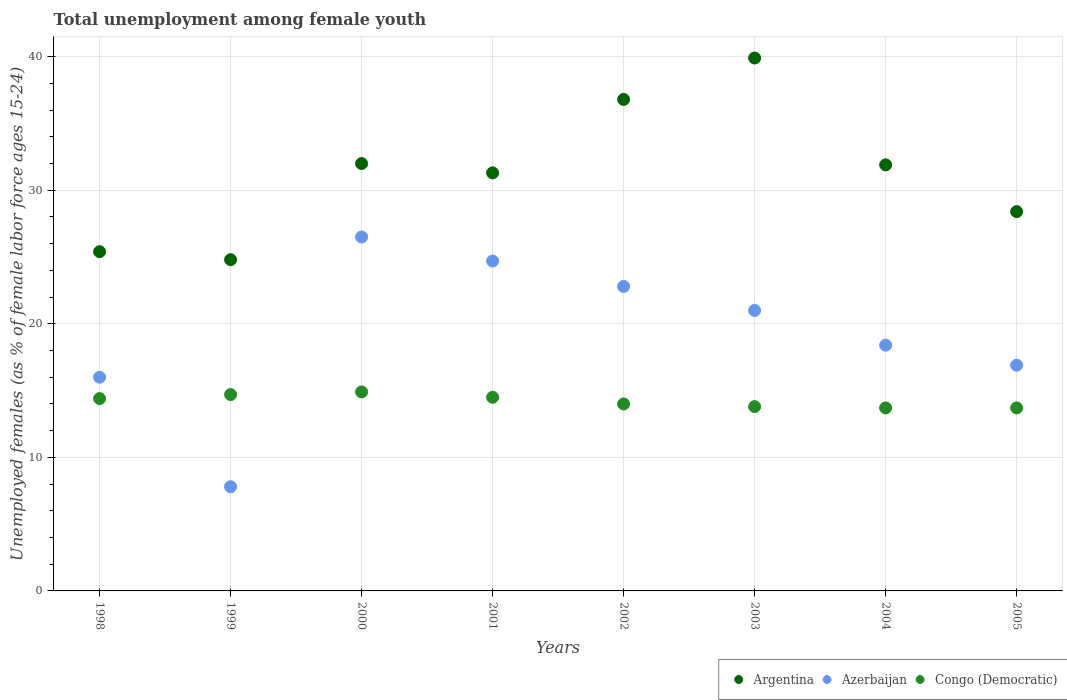How many different coloured dotlines are there?
Provide a succinct answer. 3. Is the number of dotlines equal to the number of legend labels?
Ensure brevity in your answer.  Yes. Across all years, what is the maximum percentage of unemployed females in in Argentina?
Offer a terse response. 39.9. Across all years, what is the minimum percentage of unemployed females in in Congo (Democratic)?
Ensure brevity in your answer.  13.7. In which year was the percentage of unemployed females in in Congo (Democratic) maximum?
Provide a succinct answer. 2000. In which year was the percentage of unemployed females in in Azerbaijan minimum?
Give a very brief answer. 1999. What is the total percentage of unemployed females in in Argentina in the graph?
Your answer should be compact. 250.5. What is the difference between the percentage of unemployed females in in Azerbaijan in 2000 and that in 2002?
Provide a short and direct response. 3.7. What is the difference between the percentage of unemployed females in in Congo (Democratic) in 2003 and the percentage of unemployed females in in Azerbaijan in 1999?
Ensure brevity in your answer.  6. What is the average percentage of unemployed females in in Azerbaijan per year?
Your response must be concise. 19.26. In the year 2005, what is the difference between the percentage of unemployed females in in Congo (Democratic) and percentage of unemployed females in in Azerbaijan?
Provide a succinct answer. -3.2. What is the ratio of the percentage of unemployed females in in Congo (Democratic) in 1998 to that in 2003?
Keep it short and to the point. 1.04. Is the percentage of unemployed females in in Argentina in 2000 less than that in 2001?
Make the answer very short. No. What is the difference between the highest and the second highest percentage of unemployed females in in Congo (Democratic)?
Your response must be concise. 0.2. What is the difference between the highest and the lowest percentage of unemployed females in in Argentina?
Keep it short and to the point. 15.1. Is it the case that in every year, the sum of the percentage of unemployed females in in Congo (Democratic) and percentage of unemployed females in in Azerbaijan  is greater than the percentage of unemployed females in in Argentina?
Ensure brevity in your answer.  No. Does the percentage of unemployed females in in Congo (Democratic) monotonically increase over the years?
Offer a very short reply. No. How many dotlines are there?
Offer a terse response. 3. How many years are there in the graph?
Your answer should be very brief. 8. What is the difference between two consecutive major ticks on the Y-axis?
Provide a succinct answer. 10. Are the values on the major ticks of Y-axis written in scientific E-notation?
Ensure brevity in your answer.  No. Does the graph contain grids?
Provide a succinct answer. Yes. How many legend labels are there?
Ensure brevity in your answer.  3. How are the legend labels stacked?
Offer a terse response. Horizontal. What is the title of the graph?
Provide a succinct answer. Total unemployment among female youth. Does "Sao Tome and Principe" appear as one of the legend labels in the graph?
Offer a very short reply. No. What is the label or title of the Y-axis?
Your answer should be very brief. Unemployed females (as % of female labor force ages 15-24). What is the Unemployed females (as % of female labor force ages 15-24) of Argentina in 1998?
Your answer should be very brief. 25.4. What is the Unemployed females (as % of female labor force ages 15-24) of Azerbaijan in 1998?
Offer a very short reply. 16. What is the Unemployed females (as % of female labor force ages 15-24) of Congo (Democratic) in 1998?
Make the answer very short. 14.4. What is the Unemployed females (as % of female labor force ages 15-24) in Argentina in 1999?
Provide a succinct answer. 24.8. What is the Unemployed females (as % of female labor force ages 15-24) in Azerbaijan in 1999?
Keep it short and to the point. 7.8. What is the Unemployed females (as % of female labor force ages 15-24) in Congo (Democratic) in 1999?
Your response must be concise. 14.7. What is the Unemployed females (as % of female labor force ages 15-24) in Argentina in 2000?
Offer a very short reply. 32. What is the Unemployed females (as % of female labor force ages 15-24) in Azerbaijan in 2000?
Ensure brevity in your answer.  26.5. What is the Unemployed females (as % of female labor force ages 15-24) in Congo (Democratic) in 2000?
Give a very brief answer. 14.9. What is the Unemployed females (as % of female labor force ages 15-24) in Argentina in 2001?
Your answer should be compact. 31.3. What is the Unemployed females (as % of female labor force ages 15-24) in Azerbaijan in 2001?
Provide a short and direct response. 24.7. What is the Unemployed females (as % of female labor force ages 15-24) in Congo (Democratic) in 2001?
Provide a succinct answer. 14.5. What is the Unemployed females (as % of female labor force ages 15-24) of Argentina in 2002?
Your answer should be compact. 36.8. What is the Unemployed females (as % of female labor force ages 15-24) of Azerbaijan in 2002?
Provide a short and direct response. 22.8. What is the Unemployed females (as % of female labor force ages 15-24) of Congo (Democratic) in 2002?
Give a very brief answer. 14. What is the Unemployed females (as % of female labor force ages 15-24) of Argentina in 2003?
Give a very brief answer. 39.9. What is the Unemployed females (as % of female labor force ages 15-24) of Congo (Democratic) in 2003?
Offer a terse response. 13.8. What is the Unemployed females (as % of female labor force ages 15-24) in Argentina in 2004?
Keep it short and to the point. 31.9. What is the Unemployed females (as % of female labor force ages 15-24) of Azerbaijan in 2004?
Your answer should be very brief. 18.4. What is the Unemployed females (as % of female labor force ages 15-24) of Congo (Democratic) in 2004?
Your response must be concise. 13.7. What is the Unemployed females (as % of female labor force ages 15-24) in Argentina in 2005?
Your answer should be very brief. 28.4. What is the Unemployed females (as % of female labor force ages 15-24) of Azerbaijan in 2005?
Provide a short and direct response. 16.9. What is the Unemployed females (as % of female labor force ages 15-24) of Congo (Democratic) in 2005?
Give a very brief answer. 13.7. Across all years, what is the maximum Unemployed females (as % of female labor force ages 15-24) in Argentina?
Your response must be concise. 39.9. Across all years, what is the maximum Unemployed females (as % of female labor force ages 15-24) of Congo (Democratic)?
Make the answer very short. 14.9. Across all years, what is the minimum Unemployed females (as % of female labor force ages 15-24) in Argentina?
Give a very brief answer. 24.8. Across all years, what is the minimum Unemployed females (as % of female labor force ages 15-24) in Azerbaijan?
Offer a terse response. 7.8. Across all years, what is the minimum Unemployed females (as % of female labor force ages 15-24) in Congo (Democratic)?
Make the answer very short. 13.7. What is the total Unemployed females (as % of female labor force ages 15-24) of Argentina in the graph?
Provide a succinct answer. 250.5. What is the total Unemployed females (as % of female labor force ages 15-24) of Azerbaijan in the graph?
Give a very brief answer. 154.1. What is the total Unemployed females (as % of female labor force ages 15-24) in Congo (Democratic) in the graph?
Give a very brief answer. 113.7. What is the difference between the Unemployed females (as % of female labor force ages 15-24) in Argentina in 1998 and that in 1999?
Your answer should be compact. 0.6. What is the difference between the Unemployed females (as % of female labor force ages 15-24) in Azerbaijan in 1998 and that in 1999?
Keep it short and to the point. 8.2. What is the difference between the Unemployed females (as % of female labor force ages 15-24) in Argentina in 1998 and that in 2000?
Make the answer very short. -6.6. What is the difference between the Unemployed females (as % of female labor force ages 15-24) of Azerbaijan in 1998 and that in 2000?
Give a very brief answer. -10.5. What is the difference between the Unemployed females (as % of female labor force ages 15-24) in Azerbaijan in 1998 and that in 2001?
Offer a terse response. -8.7. What is the difference between the Unemployed females (as % of female labor force ages 15-24) of Azerbaijan in 1998 and that in 2002?
Your answer should be compact. -6.8. What is the difference between the Unemployed females (as % of female labor force ages 15-24) of Argentina in 1998 and that in 2004?
Give a very brief answer. -6.5. What is the difference between the Unemployed females (as % of female labor force ages 15-24) in Argentina in 1998 and that in 2005?
Make the answer very short. -3. What is the difference between the Unemployed females (as % of female labor force ages 15-24) of Azerbaijan in 1998 and that in 2005?
Offer a terse response. -0.9. What is the difference between the Unemployed females (as % of female labor force ages 15-24) in Argentina in 1999 and that in 2000?
Your answer should be compact. -7.2. What is the difference between the Unemployed females (as % of female labor force ages 15-24) of Azerbaijan in 1999 and that in 2000?
Offer a very short reply. -18.7. What is the difference between the Unemployed females (as % of female labor force ages 15-24) of Argentina in 1999 and that in 2001?
Make the answer very short. -6.5. What is the difference between the Unemployed females (as % of female labor force ages 15-24) in Azerbaijan in 1999 and that in 2001?
Offer a terse response. -16.9. What is the difference between the Unemployed females (as % of female labor force ages 15-24) in Congo (Democratic) in 1999 and that in 2001?
Make the answer very short. 0.2. What is the difference between the Unemployed females (as % of female labor force ages 15-24) of Azerbaijan in 1999 and that in 2002?
Your answer should be compact. -15. What is the difference between the Unemployed females (as % of female labor force ages 15-24) in Congo (Democratic) in 1999 and that in 2002?
Offer a terse response. 0.7. What is the difference between the Unemployed females (as % of female labor force ages 15-24) of Argentina in 1999 and that in 2003?
Ensure brevity in your answer.  -15.1. What is the difference between the Unemployed females (as % of female labor force ages 15-24) of Argentina in 1999 and that in 2004?
Offer a very short reply. -7.1. What is the difference between the Unemployed females (as % of female labor force ages 15-24) in Azerbaijan in 1999 and that in 2004?
Offer a terse response. -10.6. What is the difference between the Unemployed females (as % of female labor force ages 15-24) in Congo (Democratic) in 1999 and that in 2004?
Offer a terse response. 1. What is the difference between the Unemployed females (as % of female labor force ages 15-24) in Azerbaijan in 1999 and that in 2005?
Provide a short and direct response. -9.1. What is the difference between the Unemployed females (as % of female labor force ages 15-24) in Congo (Democratic) in 1999 and that in 2005?
Ensure brevity in your answer.  1. What is the difference between the Unemployed females (as % of female labor force ages 15-24) of Congo (Democratic) in 2000 and that in 2001?
Your response must be concise. 0.4. What is the difference between the Unemployed females (as % of female labor force ages 15-24) in Argentina in 2000 and that in 2002?
Your response must be concise. -4.8. What is the difference between the Unemployed females (as % of female labor force ages 15-24) of Azerbaijan in 2000 and that in 2002?
Your response must be concise. 3.7. What is the difference between the Unemployed females (as % of female labor force ages 15-24) of Congo (Democratic) in 2000 and that in 2002?
Give a very brief answer. 0.9. What is the difference between the Unemployed females (as % of female labor force ages 15-24) of Argentina in 2000 and that in 2004?
Give a very brief answer. 0.1. What is the difference between the Unemployed females (as % of female labor force ages 15-24) of Azerbaijan in 2000 and that in 2004?
Provide a short and direct response. 8.1. What is the difference between the Unemployed females (as % of female labor force ages 15-24) of Argentina in 2000 and that in 2005?
Keep it short and to the point. 3.6. What is the difference between the Unemployed females (as % of female labor force ages 15-24) of Azerbaijan in 2000 and that in 2005?
Keep it short and to the point. 9.6. What is the difference between the Unemployed females (as % of female labor force ages 15-24) of Azerbaijan in 2001 and that in 2002?
Your answer should be very brief. 1.9. What is the difference between the Unemployed females (as % of female labor force ages 15-24) in Argentina in 2001 and that in 2004?
Your answer should be compact. -0.6. What is the difference between the Unemployed females (as % of female labor force ages 15-24) in Congo (Democratic) in 2001 and that in 2004?
Your answer should be compact. 0.8. What is the difference between the Unemployed females (as % of female labor force ages 15-24) in Argentina in 2001 and that in 2005?
Provide a short and direct response. 2.9. What is the difference between the Unemployed females (as % of female labor force ages 15-24) in Azerbaijan in 2001 and that in 2005?
Your response must be concise. 7.8. What is the difference between the Unemployed females (as % of female labor force ages 15-24) of Argentina in 2002 and that in 2003?
Your answer should be compact. -3.1. What is the difference between the Unemployed females (as % of female labor force ages 15-24) of Azerbaijan in 2002 and that in 2003?
Provide a short and direct response. 1.8. What is the difference between the Unemployed females (as % of female labor force ages 15-24) in Argentina in 2002 and that in 2004?
Offer a terse response. 4.9. What is the difference between the Unemployed females (as % of female labor force ages 15-24) of Azerbaijan in 2002 and that in 2004?
Your answer should be compact. 4.4. What is the difference between the Unemployed females (as % of female labor force ages 15-24) in Congo (Democratic) in 2002 and that in 2004?
Your answer should be very brief. 0.3. What is the difference between the Unemployed females (as % of female labor force ages 15-24) in Azerbaijan in 2002 and that in 2005?
Give a very brief answer. 5.9. What is the difference between the Unemployed females (as % of female labor force ages 15-24) of Congo (Democratic) in 2002 and that in 2005?
Make the answer very short. 0.3. What is the difference between the Unemployed females (as % of female labor force ages 15-24) of Azerbaijan in 2003 and that in 2004?
Your response must be concise. 2.6. What is the difference between the Unemployed females (as % of female labor force ages 15-24) of Argentina in 2004 and that in 2005?
Your answer should be compact. 3.5. What is the difference between the Unemployed females (as % of female labor force ages 15-24) of Azerbaijan in 2004 and that in 2005?
Make the answer very short. 1.5. What is the difference between the Unemployed females (as % of female labor force ages 15-24) in Congo (Democratic) in 2004 and that in 2005?
Keep it short and to the point. 0. What is the difference between the Unemployed females (as % of female labor force ages 15-24) of Argentina in 1998 and the Unemployed females (as % of female labor force ages 15-24) of Azerbaijan in 1999?
Your answer should be very brief. 17.6. What is the difference between the Unemployed females (as % of female labor force ages 15-24) in Argentina in 1998 and the Unemployed females (as % of female labor force ages 15-24) in Congo (Democratic) in 1999?
Keep it short and to the point. 10.7. What is the difference between the Unemployed females (as % of female labor force ages 15-24) in Azerbaijan in 1998 and the Unemployed females (as % of female labor force ages 15-24) in Congo (Democratic) in 1999?
Ensure brevity in your answer.  1.3. What is the difference between the Unemployed females (as % of female labor force ages 15-24) of Argentina in 1998 and the Unemployed females (as % of female labor force ages 15-24) of Congo (Democratic) in 2000?
Ensure brevity in your answer.  10.5. What is the difference between the Unemployed females (as % of female labor force ages 15-24) in Argentina in 1998 and the Unemployed females (as % of female labor force ages 15-24) in Azerbaijan in 2001?
Ensure brevity in your answer.  0.7. What is the difference between the Unemployed females (as % of female labor force ages 15-24) of Argentina in 1998 and the Unemployed females (as % of female labor force ages 15-24) of Congo (Democratic) in 2001?
Make the answer very short. 10.9. What is the difference between the Unemployed females (as % of female labor force ages 15-24) of Argentina in 1998 and the Unemployed females (as % of female labor force ages 15-24) of Azerbaijan in 2002?
Ensure brevity in your answer.  2.6. What is the difference between the Unemployed females (as % of female labor force ages 15-24) in Argentina in 1998 and the Unemployed females (as % of female labor force ages 15-24) in Congo (Democratic) in 2002?
Make the answer very short. 11.4. What is the difference between the Unemployed females (as % of female labor force ages 15-24) of Azerbaijan in 1998 and the Unemployed females (as % of female labor force ages 15-24) of Congo (Democratic) in 2002?
Make the answer very short. 2. What is the difference between the Unemployed females (as % of female labor force ages 15-24) in Argentina in 1998 and the Unemployed females (as % of female labor force ages 15-24) in Azerbaijan in 2003?
Provide a succinct answer. 4.4. What is the difference between the Unemployed females (as % of female labor force ages 15-24) in Argentina in 1998 and the Unemployed females (as % of female labor force ages 15-24) in Congo (Democratic) in 2003?
Offer a very short reply. 11.6. What is the difference between the Unemployed females (as % of female labor force ages 15-24) of Azerbaijan in 1998 and the Unemployed females (as % of female labor force ages 15-24) of Congo (Democratic) in 2003?
Give a very brief answer. 2.2. What is the difference between the Unemployed females (as % of female labor force ages 15-24) of Argentina in 1998 and the Unemployed females (as % of female labor force ages 15-24) of Azerbaijan in 2004?
Offer a very short reply. 7. What is the difference between the Unemployed females (as % of female labor force ages 15-24) of Argentina in 1998 and the Unemployed females (as % of female labor force ages 15-24) of Azerbaijan in 2005?
Ensure brevity in your answer.  8.5. What is the difference between the Unemployed females (as % of female labor force ages 15-24) in Azerbaijan in 1998 and the Unemployed females (as % of female labor force ages 15-24) in Congo (Democratic) in 2005?
Ensure brevity in your answer.  2.3. What is the difference between the Unemployed females (as % of female labor force ages 15-24) in Argentina in 1999 and the Unemployed females (as % of female labor force ages 15-24) in Azerbaijan in 2000?
Ensure brevity in your answer.  -1.7. What is the difference between the Unemployed females (as % of female labor force ages 15-24) of Argentina in 1999 and the Unemployed females (as % of female labor force ages 15-24) of Azerbaijan in 2002?
Ensure brevity in your answer.  2. What is the difference between the Unemployed females (as % of female labor force ages 15-24) in Azerbaijan in 1999 and the Unemployed females (as % of female labor force ages 15-24) in Congo (Democratic) in 2002?
Give a very brief answer. -6.2. What is the difference between the Unemployed females (as % of female labor force ages 15-24) in Argentina in 1999 and the Unemployed females (as % of female labor force ages 15-24) in Azerbaijan in 2003?
Offer a terse response. 3.8. What is the difference between the Unemployed females (as % of female labor force ages 15-24) in Argentina in 1999 and the Unemployed females (as % of female labor force ages 15-24) in Congo (Democratic) in 2003?
Your answer should be compact. 11. What is the difference between the Unemployed females (as % of female labor force ages 15-24) in Argentina in 1999 and the Unemployed females (as % of female labor force ages 15-24) in Azerbaijan in 2004?
Ensure brevity in your answer.  6.4. What is the difference between the Unemployed females (as % of female labor force ages 15-24) of Argentina in 1999 and the Unemployed females (as % of female labor force ages 15-24) of Congo (Democratic) in 2004?
Your response must be concise. 11.1. What is the difference between the Unemployed females (as % of female labor force ages 15-24) in Argentina in 2000 and the Unemployed females (as % of female labor force ages 15-24) in Azerbaijan in 2001?
Your answer should be very brief. 7.3. What is the difference between the Unemployed females (as % of female labor force ages 15-24) in Argentina in 2000 and the Unemployed females (as % of female labor force ages 15-24) in Congo (Democratic) in 2001?
Offer a terse response. 17.5. What is the difference between the Unemployed females (as % of female labor force ages 15-24) of Azerbaijan in 2000 and the Unemployed females (as % of female labor force ages 15-24) of Congo (Democratic) in 2001?
Provide a short and direct response. 12. What is the difference between the Unemployed females (as % of female labor force ages 15-24) in Argentina in 2000 and the Unemployed females (as % of female labor force ages 15-24) in Azerbaijan in 2002?
Keep it short and to the point. 9.2. What is the difference between the Unemployed females (as % of female labor force ages 15-24) in Azerbaijan in 2000 and the Unemployed females (as % of female labor force ages 15-24) in Congo (Democratic) in 2002?
Ensure brevity in your answer.  12.5. What is the difference between the Unemployed females (as % of female labor force ages 15-24) in Azerbaijan in 2000 and the Unemployed females (as % of female labor force ages 15-24) in Congo (Democratic) in 2003?
Give a very brief answer. 12.7. What is the difference between the Unemployed females (as % of female labor force ages 15-24) of Argentina in 2000 and the Unemployed females (as % of female labor force ages 15-24) of Azerbaijan in 2004?
Your answer should be compact. 13.6. What is the difference between the Unemployed females (as % of female labor force ages 15-24) in Argentina in 2000 and the Unemployed females (as % of female labor force ages 15-24) in Azerbaijan in 2005?
Give a very brief answer. 15.1. What is the difference between the Unemployed females (as % of female labor force ages 15-24) in Argentina in 2001 and the Unemployed females (as % of female labor force ages 15-24) in Azerbaijan in 2002?
Offer a terse response. 8.5. What is the difference between the Unemployed females (as % of female labor force ages 15-24) in Azerbaijan in 2001 and the Unemployed females (as % of female labor force ages 15-24) in Congo (Democratic) in 2002?
Ensure brevity in your answer.  10.7. What is the difference between the Unemployed females (as % of female labor force ages 15-24) in Argentina in 2001 and the Unemployed females (as % of female labor force ages 15-24) in Azerbaijan in 2003?
Your response must be concise. 10.3. What is the difference between the Unemployed females (as % of female labor force ages 15-24) in Argentina in 2001 and the Unemployed females (as % of female labor force ages 15-24) in Congo (Democratic) in 2003?
Give a very brief answer. 17.5. What is the difference between the Unemployed females (as % of female labor force ages 15-24) in Argentina in 2001 and the Unemployed females (as % of female labor force ages 15-24) in Azerbaijan in 2004?
Provide a succinct answer. 12.9. What is the difference between the Unemployed females (as % of female labor force ages 15-24) of Azerbaijan in 2001 and the Unemployed females (as % of female labor force ages 15-24) of Congo (Democratic) in 2004?
Make the answer very short. 11. What is the difference between the Unemployed females (as % of female labor force ages 15-24) of Argentina in 2001 and the Unemployed females (as % of female labor force ages 15-24) of Azerbaijan in 2005?
Your response must be concise. 14.4. What is the difference between the Unemployed females (as % of female labor force ages 15-24) of Azerbaijan in 2001 and the Unemployed females (as % of female labor force ages 15-24) of Congo (Democratic) in 2005?
Provide a succinct answer. 11. What is the difference between the Unemployed females (as % of female labor force ages 15-24) in Argentina in 2002 and the Unemployed females (as % of female labor force ages 15-24) in Azerbaijan in 2003?
Keep it short and to the point. 15.8. What is the difference between the Unemployed females (as % of female labor force ages 15-24) in Azerbaijan in 2002 and the Unemployed females (as % of female labor force ages 15-24) in Congo (Democratic) in 2003?
Offer a terse response. 9. What is the difference between the Unemployed females (as % of female labor force ages 15-24) of Argentina in 2002 and the Unemployed females (as % of female labor force ages 15-24) of Azerbaijan in 2004?
Your response must be concise. 18.4. What is the difference between the Unemployed females (as % of female labor force ages 15-24) in Argentina in 2002 and the Unemployed females (as % of female labor force ages 15-24) in Congo (Democratic) in 2004?
Give a very brief answer. 23.1. What is the difference between the Unemployed females (as % of female labor force ages 15-24) in Azerbaijan in 2002 and the Unemployed females (as % of female labor force ages 15-24) in Congo (Democratic) in 2004?
Give a very brief answer. 9.1. What is the difference between the Unemployed females (as % of female labor force ages 15-24) of Argentina in 2002 and the Unemployed females (as % of female labor force ages 15-24) of Congo (Democratic) in 2005?
Your answer should be very brief. 23.1. What is the difference between the Unemployed females (as % of female labor force ages 15-24) of Azerbaijan in 2002 and the Unemployed females (as % of female labor force ages 15-24) of Congo (Democratic) in 2005?
Your answer should be very brief. 9.1. What is the difference between the Unemployed females (as % of female labor force ages 15-24) in Argentina in 2003 and the Unemployed females (as % of female labor force ages 15-24) in Congo (Democratic) in 2004?
Keep it short and to the point. 26.2. What is the difference between the Unemployed females (as % of female labor force ages 15-24) in Argentina in 2003 and the Unemployed females (as % of female labor force ages 15-24) in Azerbaijan in 2005?
Give a very brief answer. 23. What is the difference between the Unemployed females (as % of female labor force ages 15-24) of Argentina in 2003 and the Unemployed females (as % of female labor force ages 15-24) of Congo (Democratic) in 2005?
Ensure brevity in your answer.  26.2. What is the difference between the Unemployed females (as % of female labor force ages 15-24) of Argentina in 2004 and the Unemployed females (as % of female labor force ages 15-24) of Azerbaijan in 2005?
Keep it short and to the point. 15. What is the average Unemployed females (as % of female labor force ages 15-24) of Argentina per year?
Offer a very short reply. 31.31. What is the average Unemployed females (as % of female labor force ages 15-24) in Azerbaijan per year?
Offer a very short reply. 19.26. What is the average Unemployed females (as % of female labor force ages 15-24) in Congo (Democratic) per year?
Offer a very short reply. 14.21. In the year 1998, what is the difference between the Unemployed females (as % of female labor force ages 15-24) in Argentina and Unemployed females (as % of female labor force ages 15-24) in Azerbaijan?
Provide a short and direct response. 9.4. In the year 1998, what is the difference between the Unemployed females (as % of female labor force ages 15-24) in Argentina and Unemployed females (as % of female labor force ages 15-24) in Congo (Democratic)?
Offer a terse response. 11. In the year 1999, what is the difference between the Unemployed females (as % of female labor force ages 15-24) of Argentina and Unemployed females (as % of female labor force ages 15-24) of Azerbaijan?
Provide a succinct answer. 17. In the year 1999, what is the difference between the Unemployed females (as % of female labor force ages 15-24) in Azerbaijan and Unemployed females (as % of female labor force ages 15-24) in Congo (Democratic)?
Make the answer very short. -6.9. In the year 2001, what is the difference between the Unemployed females (as % of female labor force ages 15-24) of Argentina and Unemployed females (as % of female labor force ages 15-24) of Congo (Democratic)?
Your answer should be compact. 16.8. In the year 2001, what is the difference between the Unemployed females (as % of female labor force ages 15-24) in Azerbaijan and Unemployed females (as % of female labor force ages 15-24) in Congo (Democratic)?
Give a very brief answer. 10.2. In the year 2002, what is the difference between the Unemployed females (as % of female labor force ages 15-24) of Argentina and Unemployed females (as % of female labor force ages 15-24) of Congo (Democratic)?
Offer a very short reply. 22.8. In the year 2002, what is the difference between the Unemployed females (as % of female labor force ages 15-24) in Azerbaijan and Unemployed females (as % of female labor force ages 15-24) in Congo (Democratic)?
Your answer should be very brief. 8.8. In the year 2003, what is the difference between the Unemployed females (as % of female labor force ages 15-24) in Argentina and Unemployed females (as % of female labor force ages 15-24) in Azerbaijan?
Ensure brevity in your answer.  18.9. In the year 2003, what is the difference between the Unemployed females (as % of female labor force ages 15-24) in Argentina and Unemployed females (as % of female labor force ages 15-24) in Congo (Democratic)?
Offer a very short reply. 26.1. In the year 2003, what is the difference between the Unemployed females (as % of female labor force ages 15-24) of Azerbaijan and Unemployed females (as % of female labor force ages 15-24) of Congo (Democratic)?
Make the answer very short. 7.2. What is the ratio of the Unemployed females (as % of female labor force ages 15-24) of Argentina in 1998 to that in 1999?
Provide a short and direct response. 1.02. What is the ratio of the Unemployed females (as % of female labor force ages 15-24) of Azerbaijan in 1998 to that in 1999?
Keep it short and to the point. 2.05. What is the ratio of the Unemployed females (as % of female labor force ages 15-24) in Congo (Democratic) in 1998 to that in 1999?
Provide a short and direct response. 0.98. What is the ratio of the Unemployed females (as % of female labor force ages 15-24) in Argentina in 1998 to that in 2000?
Ensure brevity in your answer.  0.79. What is the ratio of the Unemployed females (as % of female labor force ages 15-24) of Azerbaijan in 1998 to that in 2000?
Offer a terse response. 0.6. What is the ratio of the Unemployed females (as % of female labor force ages 15-24) in Congo (Democratic) in 1998 to that in 2000?
Give a very brief answer. 0.97. What is the ratio of the Unemployed females (as % of female labor force ages 15-24) in Argentina in 1998 to that in 2001?
Give a very brief answer. 0.81. What is the ratio of the Unemployed females (as % of female labor force ages 15-24) in Azerbaijan in 1998 to that in 2001?
Your answer should be very brief. 0.65. What is the ratio of the Unemployed females (as % of female labor force ages 15-24) of Congo (Democratic) in 1998 to that in 2001?
Provide a short and direct response. 0.99. What is the ratio of the Unemployed females (as % of female labor force ages 15-24) of Argentina in 1998 to that in 2002?
Your response must be concise. 0.69. What is the ratio of the Unemployed females (as % of female labor force ages 15-24) of Azerbaijan in 1998 to that in 2002?
Provide a short and direct response. 0.7. What is the ratio of the Unemployed females (as % of female labor force ages 15-24) of Congo (Democratic) in 1998 to that in 2002?
Give a very brief answer. 1.03. What is the ratio of the Unemployed females (as % of female labor force ages 15-24) of Argentina in 1998 to that in 2003?
Give a very brief answer. 0.64. What is the ratio of the Unemployed females (as % of female labor force ages 15-24) of Azerbaijan in 1998 to that in 2003?
Keep it short and to the point. 0.76. What is the ratio of the Unemployed females (as % of female labor force ages 15-24) in Congo (Democratic) in 1998 to that in 2003?
Keep it short and to the point. 1.04. What is the ratio of the Unemployed females (as % of female labor force ages 15-24) in Argentina in 1998 to that in 2004?
Your answer should be very brief. 0.8. What is the ratio of the Unemployed females (as % of female labor force ages 15-24) of Azerbaijan in 1998 to that in 2004?
Ensure brevity in your answer.  0.87. What is the ratio of the Unemployed females (as % of female labor force ages 15-24) in Congo (Democratic) in 1998 to that in 2004?
Keep it short and to the point. 1.05. What is the ratio of the Unemployed females (as % of female labor force ages 15-24) of Argentina in 1998 to that in 2005?
Give a very brief answer. 0.89. What is the ratio of the Unemployed females (as % of female labor force ages 15-24) of Azerbaijan in 1998 to that in 2005?
Make the answer very short. 0.95. What is the ratio of the Unemployed females (as % of female labor force ages 15-24) of Congo (Democratic) in 1998 to that in 2005?
Make the answer very short. 1.05. What is the ratio of the Unemployed females (as % of female labor force ages 15-24) of Argentina in 1999 to that in 2000?
Offer a terse response. 0.78. What is the ratio of the Unemployed females (as % of female labor force ages 15-24) in Azerbaijan in 1999 to that in 2000?
Offer a very short reply. 0.29. What is the ratio of the Unemployed females (as % of female labor force ages 15-24) of Congo (Democratic) in 1999 to that in 2000?
Give a very brief answer. 0.99. What is the ratio of the Unemployed females (as % of female labor force ages 15-24) of Argentina in 1999 to that in 2001?
Keep it short and to the point. 0.79. What is the ratio of the Unemployed females (as % of female labor force ages 15-24) in Azerbaijan in 1999 to that in 2001?
Keep it short and to the point. 0.32. What is the ratio of the Unemployed females (as % of female labor force ages 15-24) of Congo (Democratic) in 1999 to that in 2001?
Your response must be concise. 1.01. What is the ratio of the Unemployed females (as % of female labor force ages 15-24) of Argentina in 1999 to that in 2002?
Offer a very short reply. 0.67. What is the ratio of the Unemployed females (as % of female labor force ages 15-24) of Azerbaijan in 1999 to that in 2002?
Ensure brevity in your answer.  0.34. What is the ratio of the Unemployed females (as % of female labor force ages 15-24) of Congo (Democratic) in 1999 to that in 2002?
Provide a short and direct response. 1.05. What is the ratio of the Unemployed females (as % of female labor force ages 15-24) of Argentina in 1999 to that in 2003?
Give a very brief answer. 0.62. What is the ratio of the Unemployed females (as % of female labor force ages 15-24) in Azerbaijan in 1999 to that in 2003?
Provide a succinct answer. 0.37. What is the ratio of the Unemployed females (as % of female labor force ages 15-24) in Congo (Democratic) in 1999 to that in 2003?
Ensure brevity in your answer.  1.07. What is the ratio of the Unemployed females (as % of female labor force ages 15-24) in Argentina in 1999 to that in 2004?
Your answer should be compact. 0.78. What is the ratio of the Unemployed females (as % of female labor force ages 15-24) of Azerbaijan in 1999 to that in 2004?
Make the answer very short. 0.42. What is the ratio of the Unemployed females (as % of female labor force ages 15-24) in Congo (Democratic) in 1999 to that in 2004?
Keep it short and to the point. 1.07. What is the ratio of the Unemployed females (as % of female labor force ages 15-24) of Argentina in 1999 to that in 2005?
Give a very brief answer. 0.87. What is the ratio of the Unemployed females (as % of female labor force ages 15-24) of Azerbaijan in 1999 to that in 2005?
Your answer should be compact. 0.46. What is the ratio of the Unemployed females (as % of female labor force ages 15-24) in Congo (Democratic) in 1999 to that in 2005?
Your response must be concise. 1.07. What is the ratio of the Unemployed females (as % of female labor force ages 15-24) of Argentina in 2000 to that in 2001?
Provide a succinct answer. 1.02. What is the ratio of the Unemployed females (as % of female labor force ages 15-24) of Azerbaijan in 2000 to that in 2001?
Give a very brief answer. 1.07. What is the ratio of the Unemployed females (as % of female labor force ages 15-24) of Congo (Democratic) in 2000 to that in 2001?
Provide a succinct answer. 1.03. What is the ratio of the Unemployed females (as % of female labor force ages 15-24) of Argentina in 2000 to that in 2002?
Keep it short and to the point. 0.87. What is the ratio of the Unemployed females (as % of female labor force ages 15-24) in Azerbaijan in 2000 to that in 2002?
Your answer should be very brief. 1.16. What is the ratio of the Unemployed females (as % of female labor force ages 15-24) in Congo (Democratic) in 2000 to that in 2002?
Make the answer very short. 1.06. What is the ratio of the Unemployed females (as % of female labor force ages 15-24) of Argentina in 2000 to that in 2003?
Your response must be concise. 0.8. What is the ratio of the Unemployed females (as % of female labor force ages 15-24) in Azerbaijan in 2000 to that in 2003?
Ensure brevity in your answer.  1.26. What is the ratio of the Unemployed females (as % of female labor force ages 15-24) of Congo (Democratic) in 2000 to that in 2003?
Your answer should be very brief. 1.08. What is the ratio of the Unemployed females (as % of female labor force ages 15-24) of Azerbaijan in 2000 to that in 2004?
Offer a very short reply. 1.44. What is the ratio of the Unemployed females (as % of female labor force ages 15-24) of Congo (Democratic) in 2000 to that in 2004?
Offer a very short reply. 1.09. What is the ratio of the Unemployed females (as % of female labor force ages 15-24) of Argentina in 2000 to that in 2005?
Your answer should be compact. 1.13. What is the ratio of the Unemployed females (as % of female labor force ages 15-24) of Azerbaijan in 2000 to that in 2005?
Offer a very short reply. 1.57. What is the ratio of the Unemployed females (as % of female labor force ages 15-24) of Congo (Democratic) in 2000 to that in 2005?
Provide a succinct answer. 1.09. What is the ratio of the Unemployed females (as % of female labor force ages 15-24) of Argentina in 2001 to that in 2002?
Give a very brief answer. 0.85. What is the ratio of the Unemployed females (as % of female labor force ages 15-24) of Congo (Democratic) in 2001 to that in 2002?
Keep it short and to the point. 1.04. What is the ratio of the Unemployed females (as % of female labor force ages 15-24) of Argentina in 2001 to that in 2003?
Your answer should be very brief. 0.78. What is the ratio of the Unemployed females (as % of female labor force ages 15-24) of Azerbaijan in 2001 to that in 2003?
Ensure brevity in your answer.  1.18. What is the ratio of the Unemployed females (as % of female labor force ages 15-24) in Congo (Democratic) in 2001 to that in 2003?
Give a very brief answer. 1.05. What is the ratio of the Unemployed females (as % of female labor force ages 15-24) of Argentina in 2001 to that in 2004?
Make the answer very short. 0.98. What is the ratio of the Unemployed females (as % of female labor force ages 15-24) in Azerbaijan in 2001 to that in 2004?
Give a very brief answer. 1.34. What is the ratio of the Unemployed females (as % of female labor force ages 15-24) in Congo (Democratic) in 2001 to that in 2004?
Ensure brevity in your answer.  1.06. What is the ratio of the Unemployed females (as % of female labor force ages 15-24) of Argentina in 2001 to that in 2005?
Give a very brief answer. 1.1. What is the ratio of the Unemployed females (as % of female labor force ages 15-24) in Azerbaijan in 2001 to that in 2005?
Provide a short and direct response. 1.46. What is the ratio of the Unemployed females (as % of female labor force ages 15-24) in Congo (Democratic) in 2001 to that in 2005?
Your answer should be compact. 1.06. What is the ratio of the Unemployed females (as % of female labor force ages 15-24) in Argentina in 2002 to that in 2003?
Your answer should be very brief. 0.92. What is the ratio of the Unemployed females (as % of female labor force ages 15-24) of Azerbaijan in 2002 to that in 2003?
Keep it short and to the point. 1.09. What is the ratio of the Unemployed females (as % of female labor force ages 15-24) of Congo (Democratic) in 2002 to that in 2003?
Your answer should be compact. 1.01. What is the ratio of the Unemployed females (as % of female labor force ages 15-24) in Argentina in 2002 to that in 2004?
Give a very brief answer. 1.15. What is the ratio of the Unemployed females (as % of female labor force ages 15-24) in Azerbaijan in 2002 to that in 2004?
Your response must be concise. 1.24. What is the ratio of the Unemployed females (as % of female labor force ages 15-24) of Congo (Democratic) in 2002 to that in 2004?
Your answer should be compact. 1.02. What is the ratio of the Unemployed females (as % of female labor force ages 15-24) in Argentina in 2002 to that in 2005?
Give a very brief answer. 1.3. What is the ratio of the Unemployed females (as % of female labor force ages 15-24) of Azerbaijan in 2002 to that in 2005?
Your answer should be compact. 1.35. What is the ratio of the Unemployed females (as % of female labor force ages 15-24) of Congo (Democratic) in 2002 to that in 2005?
Your answer should be compact. 1.02. What is the ratio of the Unemployed females (as % of female labor force ages 15-24) in Argentina in 2003 to that in 2004?
Your answer should be compact. 1.25. What is the ratio of the Unemployed females (as % of female labor force ages 15-24) of Azerbaijan in 2003 to that in 2004?
Your answer should be compact. 1.14. What is the ratio of the Unemployed females (as % of female labor force ages 15-24) of Congo (Democratic) in 2003 to that in 2004?
Keep it short and to the point. 1.01. What is the ratio of the Unemployed females (as % of female labor force ages 15-24) in Argentina in 2003 to that in 2005?
Keep it short and to the point. 1.4. What is the ratio of the Unemployed females (as % of female labor force ages 15-24) in Azerbaijan in 2003 to that in 2005?
Provide a succinct answer. 1.24. What is the ratio of the Unemployed females (as % of female labor force ages 15-24) of Congo (Democratic) in 2003 to that in 2005?
Your answer should be compact. 1.01. What is the ratio of the Unemployed females (as % of female labor force ages 15-24) of Argentina in 2004 to that in 2005?
Give a very brief answer. 1.12. What is the ratio of the Unemployed females (as % of female labor force ages 15-24) of Azerbaijan in 2004 to that in 2005?
Offer a terse response. 1.09. What is the difference between the highest and the second highest Unemployed females (as % of female labor force ages 15-24) in Argentina?
Ensure brevity in your answer.  3.1. What is the difference between the highest and the second highest Unemployed females (as % of female labor force ages 15-24) of Azerbaijan?
Give a very brief answer. 1.8. What is the difference between the highest and the lowest Unemployed females (as % of female labor force ages 15-24) in Argentina?
Provide a short and direct response. 15.1. 